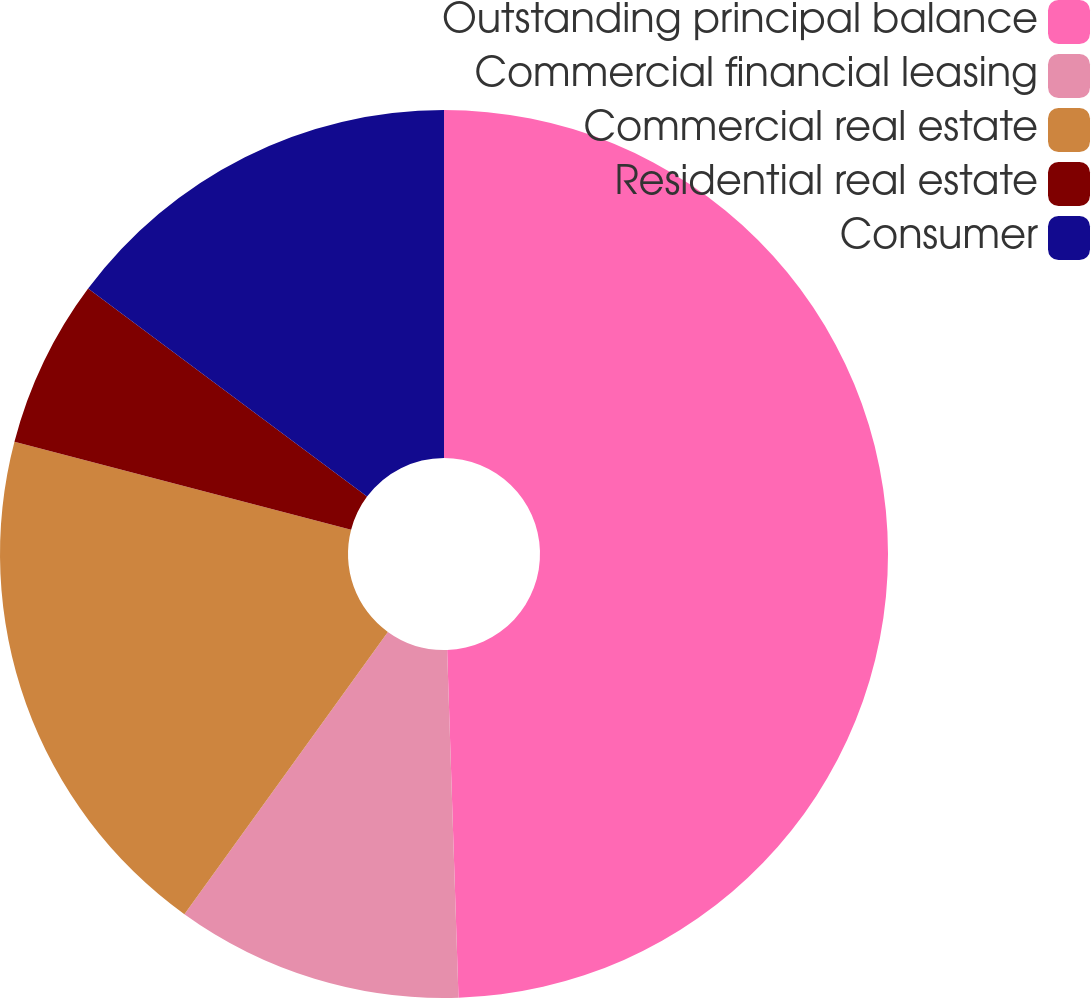Convert chart. <chart><loc_0><loc_0><loc_500><loc_500><pie_chart><fcel>Outstanding principal balance<fcel>Commercial financial leasing<fcel>Commercial real estate<fcel>Residential real estate<fcel>Consumer<nl><fcel>49.48%<fcel>10.46%<fcel>19.13%<fcel>6.13%<fcel>14.8%<nl></chart> 